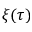<formula> <loc_0><loc_0><loc_500><loc_500>\xi ( \tau )</formula> 